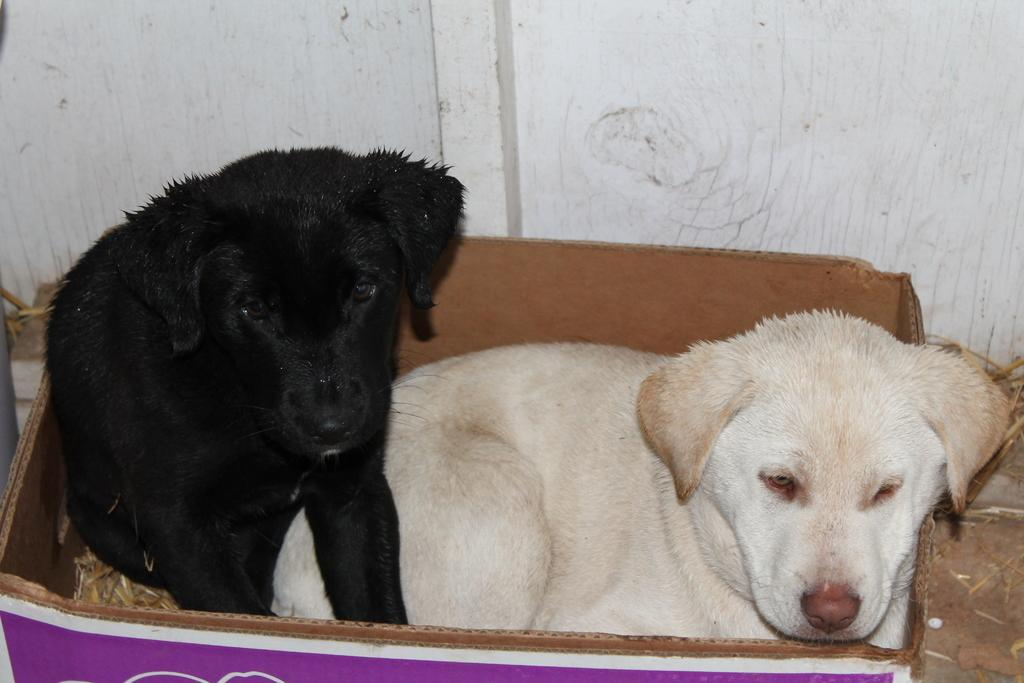What type of animal is present in the image? There is a dog in the image. Can you describe the color of the dog? The dog is black and white in color. Where is the dog located in the image? The dog is present in a cardboard box. What type of neck accessory is the dog wearing in the image? There is no neck accessory visible on the dog in the image. 